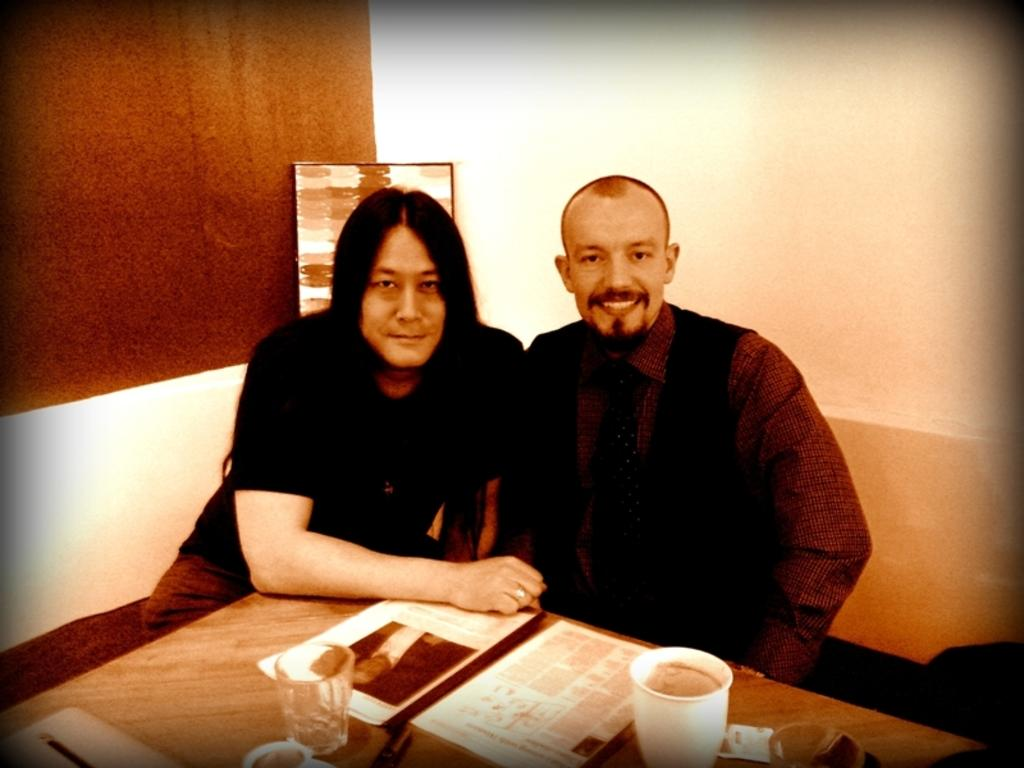How many people are sitting on the sofa in the image? There are two persons sitting on the sofa in the image. What is located near the sofa? There is a table in the image. What items can be seen on the table? There are papers and glasses on the table. What can be seen in the background of the image? There is a wall in the background of the image. What type of object is present in the image? There is a frame in the image. What type of waste is being disposed of by the farmer in the image? There is no farmer or waste present in the image. What type of voyage are the two persons on the sofa planning in the image? There is no indication of a voyage or travel plans in the image. 